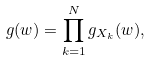Convert formula to latex. <formula><loc_0><loc_0><loc_500><loc_500>g ( w ) = \prod _ { k = 1 } ^ { N } g _ { X _ { k } } ( w ) ,</formula> 